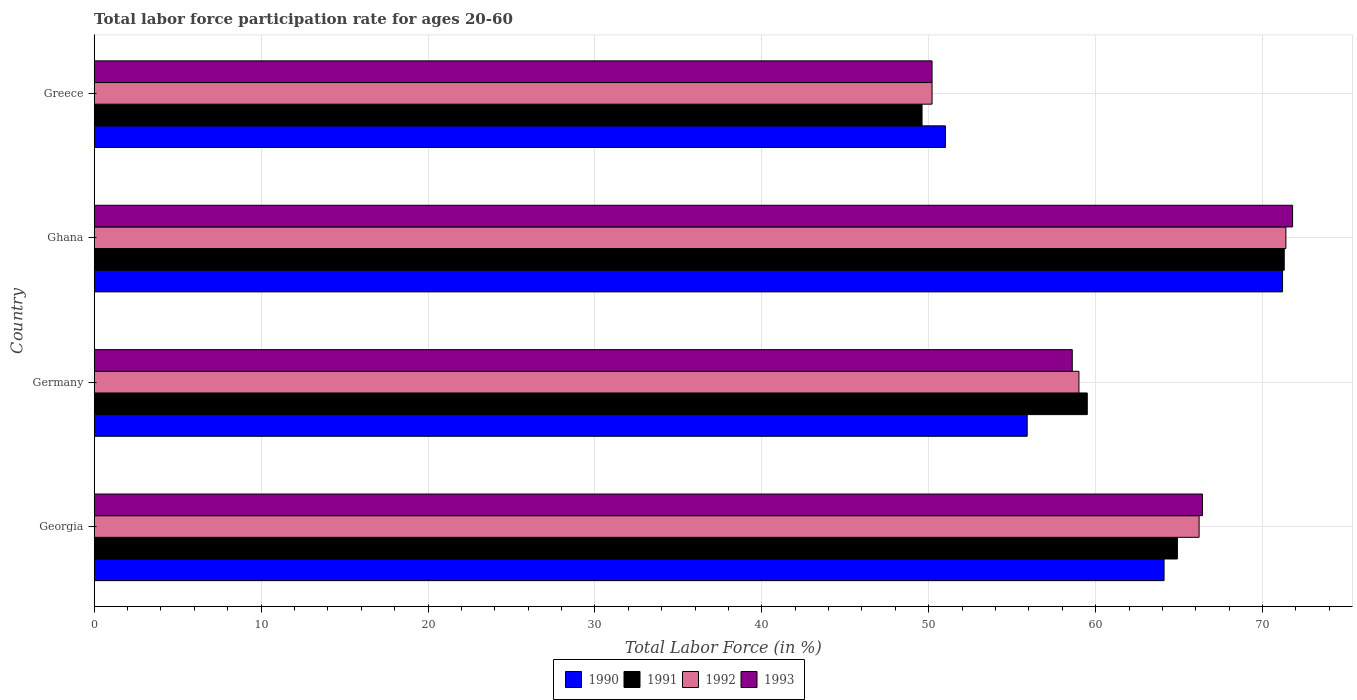Are the number of bars on each tick of the Y-axis equal?
Offer a terse response. Yes. What is the labor force participation rate in 1991 in Georgia?
Offer a terse response. 64.9. Across all countries, what is the maximum labor force participation rate in 1992?
Your answer should be very brief. 71.4. Across all countries, what is the minimum labor force participation rate in 1992?
Give a very brief answer. 50.2. In which country was the labor force participation rate in 1992 maximum?
Keep it short and to the point. Ghana. What is the total labor force participation rate in 1993 in the graph?
Keep it short and to the point. 247. What is the difference between the labor force participation rate in 1993 in Georgia and that in Germany?
Offer a very short reply. 7.8. What is the difference between the labor force participation rate in 1992 in Ghana and the labor force participation rate in 1991 in Germany?
Provide a succinct answer. 11.9. What is the average labor force participation rate in 1992 per country?
Your answer should be compact. 61.7. What is the difference between the labor force participation rate in 1991 and labor force participation rate in 1992 in Georgia?
Provide a short and direct response. -1.3. In how many countries, is the labor force participation rate in 1990 greater than 70 %?
Give a very brief answer. 1. What is the ratio of the labor force participation rate in 1992 in Germany to that in Greece?
Make the answer very short. 1.18. Is the difference between the labor force participation rate in 1991 in Ghana and Greece greater than the difference between the labor force participation rate in 1992 in Ghana and Greece?
Provide a short and direct response. Yes. What is the difference between the highest and the second highest labor force participation rate in 1993?
Your response must be concise. 5.4. What is the difference between the highest and the lowest labor force participation rate in 1992?
Give a very brief answer. 21.2. Is the sum of the labor force participation rate in 1990 in Germany and Ghana greater than the maximum labor force participation rate in 1992 across all countries?
Offer a terse response. Yes. Is it the case that in every country, the sum of the labor force participation rate in 1992 and labor force participation rate in 1990 is greater than the sum of labor force participation rate in 1993 and labor force participation rate in 1991?
Provide a short and direct response. No. What does the 2nd bar from the top in Germany represents?
Offer a very short reply. 1992. Are the values on the major ticks of X-axis written in scientific E-notation?
Offer a very short reply. No. Does the graph contain any zero values?
Make the answer very short. No. Where does the legend appear in the graph?
Keep it short and to the point. Bottom center. How many legend labels are there?
Keep it short and to the point. 4. What is the title of the graph?
Provide a succinct answer. Total labor force participation rate for ages 20-60. Does "1991" appear as one of the legend labels in the graph?
Offer a very short reply. Yes. What is the label or title of the X-axis?
Offer a terse response. Total Labor Force (in %). What is the Total Labor Force (in %) in 1990 in Georgia?
Your answer should be compact. 64.1. What is the Total Labor Force (in %) of 1991 in Georgia?
Offer a very short reply. 64.9. What is the Total Labor Force (in %) in 1992 in Georgia?
Your answer should be compact. 66.2. What is the Total Labor Force (in %) of 1993 in Georgia?
Provide a succinct answer. 66.4. What is the Total Labor Force (in %) of 1990 in Germany?
Your answer should be compact. 55.9. What is the Total Labor Force (in %) in 1991 in Germany?
Make the answer very short. 59.5. What is the Total Labor Force (in %) of 1993 in Germany?
Keep it short and to the point. 58.6. What is the Total Labor Force (in %) in 1990 in Ghana?
Offer a terse response. 71.2. What is the Total Labor Force (in %) of 1991 in Ghana?
Provide a short and direct response. 71.3. What is the Total Labor Force (in %) of 1992 in Ghana?
Keep it short and to the point. 71.4. What is the Total Labor Force (in %) in 1993 in Ghana?
Provide a succinct answer. 71.8. What is the Total Labor Force (in %) of 1990 in Greece?
Your answer should be very brief. 51. What is the Total Labor Force (in %) in 1991 in Greece?
Make the answer very short. 49.6. What is the Total Labor Force (in %) of 1992 in Greece?
Make the answer very short. 50.2. What is the Total Labor Force (in %) of 1993 in Greece?
Offer a terse response. 50.2. Across all countries, what is the maximum Total Labor Force (in %) in 1990?
Give a very brief answer. 71.2. Across all countries, what is the maximum Total Labor Force (in %) of 1991?
Your answer should be very brief. 71.3. Across all countries, what is the maximum Total Labor Force (in %) in 1992?
Your answer should be very brief. 71.4. Across all countries, what is the maximum Total Labor Force (in %) in 1993?
Provide a short and direct response. 71.8. Across all countries, what is the minimum Total Labor Force (in %) in 1990?
Ensure brevity in your answer.  51. Across all countries, what is the minimum Total Labor Force (in %) in 1991?
Your response must be concise. 49.6. Across all countries, what is the minimum Total Labor Force (in %) of 1992?
Offer a very short reply. 50.2. Across all countries, what is the minimum Total Labor Force (in %) of 1993?
Offer a terse response. 50.2. What is the total Total Labor Force (in %) in 1990 in the graph?
Keep it short and to the point. 242.2. What is the total Total Labor Force (in %) of 1991 in the graph?
Your response must be concise. 245.3. What is the total Total Labor Force (in %) in 1992 in the graph?
Give a very brief answer. 246.8. What is the total Total Labor Force (in %) in 1993 in the graph?
Give a very brief answer. 247. What is the difference between the Total Labor Force (in %) of 1990 in Georgia and that in Germany?
Provide a succinct answer. 8.2. What is the difference between the Total Labor Force (in %) of 1993 in Georgia and that in Greece?
Your answer should be very brief. 16.2. What is the difference between the Total Labor Force (in %) in 1990 in Germany and that in Ghana?
Make the answer very short. -15.3. What is the difference between the Total Labor Force (in %) of 1991 in Germany and that in Ghana?
Make the answer very short. -11.8. What is the difference between the Total Labor Force (in %) in 1993 in Germany and that in Ghana?
Your answer should be compact. -13.2. What is the difference between the Total Labor Force (in %) in 1990 in Germany and that in Greece?
Keep it short and to the point. 4.9. What is the difference between the Total Labor Force (in %) of 1991 in Germany and that in Greece?
Provide a succinct answer. 9.9. What is the difference between the Total Labor Force (in %) in 1992 in Germany and that in Greece?
Provide a short and direct response. 8.8. What is the difference between the Total Labor Force (in %) of 1990 in Ghana and that in Greece?
Your answer should be very brief. 20.2. What is the difference between the Total Labor Force (in %) in 1991 in Ghana and that in Greece?
Ensure brevity in your answer.  21.7. What is the difference between the Total Labor Force (in %) in 1992 in Ghana and that in Greece?
Offer a very short reply. 21.2. What is the difference between the Total Labor Force (in %) in 1993 in Ghana and that in Greece?
Your answer should be very brief. 21.6. What is the difference between the Total Labor Force (in %) of 1990 in Georgia and the Total Labor Force (in %) of 1991 in Germany?
Offer a very short reply. 4.6. What is the difference between the Total Labor Force (in %) of 1990 in Georgia and the Total Labor Force (in %) of 1992 in Germany?
Offer a terse response. 5.1. What is the difference between the Total Labor Force (in %) in 1990 in Georgia and the Total Labor Force (in %) in 1993 in Germany?
Ensure brevity in your answer.  5.5. What is the difference between the Total Labor Force (in %) of 1992 in Georgia and the Total Labor Force (in %) of 1993 in Germany?
Keep it short and to the point. 7.6. What is the difference between the Total Labor Force (in %) of 1990 in Georgia and the Total Labor Force (in %) of 1993 in Ghana?
Offer a very short reply. -7.7. What is the difference between the Total Labor Force (in %) in 1991 in Georgia and the Total Labor Force (in %) in 1992 in Ghana?
Your answer should be very brief. -6.5. What is the difference between the Total Labor Force (in %) in 1992 in Georgia and the Total Labor Force (in %) in 1993 in Ghana?
Your response must be concise. -5.6. What is the difference between the Total Labor Force (in %) of 1990 in Georgia and the Total Labor Force (in %) of 1991 in Greece?
Your answer should be compact. 14.5. What is the difference between the Total Labor Force (in %) of 1990 in Georgia and the Total Labor Force (in %) of 1992 in Greece?
Your response must be concise. 13.9. What is the difference between the Total Labor Force (in %) in 1990 in Georgia and the Total Labor Force (in %) in 1993 in Greece?
Offer a very short reply. 13.9. What is the difference between the Total Labor Force (in %) in 1991 in Georgia and the Total Labor Force (in %) in 1992 in Greece?
Offer a very short reply. 14.7. What is the difference between the Total Labor Force (in %) in 1992 in Georgia and the Total Labor Force (in %) in 1993 in Greece?
Keep it short and to the point. 16. What is the difference between the Total Labor Force (in %) in 1990 in Germany and the Total Labor Force (in %) in 1991 in Ghana?
Your answer should be very brief. -15.4. What is the difference between the Total Labor Force (in %) in 1990 in Germany and the Total Labor Force (in %) in 1992 in Ghana?
Provide a short and direct response. -15.5. What is the difference between the Total Labor Force (in %) of 1990 in Germany and the Total Labor Force (in %) of 1993 in Ghana?
Ensure brevity in your answer.  -15.9. What is the difference between the Total Labor Force (in %) of 1991 in Germany and the Total Labor Force (in %) of 1992 in Ghana?
Provide a succinct answer. -11.9. What is the difference between the Total Labor Force (in %) in 1991 in Germany and the Total Labor Force (in %) in 1993 in Ghana?
Offer a terse response. -12.3. What is the difference between the Total Labor Force (in %) of 1992 in Germany and the Total Labor Force (in %) of 1993 in Ghana?
Offer a terse response. -12.8. What is the difference between the Total Labor Force (in %) of 1990 in Germany and the Total Labor Force (in %) of 1993 in Greece?
Keep it short and to the point. 5.7. What is the difference between the Total Labor Force (in %) in 1991 in Germany and the Total Labor Force (in %) in 1993 in Greece?
Provide a short and direct response. 9.3. What is the difference between the Total Labor Force (in %) in 1990 in Ghana and the Total Labor Force (in %) in 1991 in Greece?
Your answer should be very brief. 21.6. What is the difference between the Total Labor Force (in %) of 1990 in Ghana and the Total Labor Force (in %) of 1992 in Greece?
Offer a terse response. 21. What is the difference between the Total Labor Force (in %) in 1990 in Ghana and the Total Labor Force (in %) in 1993 in Greece?
Ensure brevity in your answer.  21. What is the difference between the Total Labor Force (in %) in 1991 in Ghana and the Total Labor Force (in %) in 1992 in Greece?
Make the answer very short. 21.1. What is the difference between the Total Labor Force (in %) of 1991 in Ghana and the Total Labor Force (in %) of 1993 in Greece?
Keep it short and to the point. 21.1. What is the difference between the Total Labor Force (in %) of 1992 in Ghana and the Total Labor Force (in %) of 1993 in Greece?
Give a very brief answer. 21.2. What is the average Total Labor Force (in %) in 1990 per country?
Ensure brevity in your answer.  60.55. What is the average Total Labor Force (in %) of 1991 per country?
Offer a terse response. 61.33. What is the average Total Labor Force (in %) of 1992 per country?
Offer a very short reply. 61.7. What is the average Total Labor Force (in %) in 1993 per country?
Make the answer very short. 61.75. What is the difference between the Total Labor Force (in %) in 1990 and Total Labor Force (in %) in 1991 in Georgia?
Make the answer very short. -0.8. What is the difference between the Total Labor Force (in %) of 1990 and Total Labor Force (in %) of 1992 in Georgia?
Offer a very short reply. -2.1. What is the difference between the Total Labor Force (in %) in 1990 and Total Labor Force (in %) in 1993 in Georgia?
Offer a very short reply. -2.3. What is the difference between the Total Labor Force (in %) in 1991 and Total Labor Force (in %) in 1992 in Georgia?
Keep it short and to the point. -1.3. What is the difference between the Total Labor Force (in %) in 1991 and Total Labor Force (in %) in 1993 in Georgia?
Your answer should be compact. -1.5. What is the difference between the Total Labor Force (in %) of 1991 and Total Labor Force (in %) of 1992 in Germany?
Make the answer very short. 0.5. What is the difference between the Total Labor Force (in %) in 1990 and Total Labor Force (in %) in 1993 in Ghana?
Provide a short and direct response. -0.6. What is the difference between the Total Labor Force (in %) of 1991 and Total Labor Force (in %) of 1993 in Ghana?
Give a very brief answer. -0.5. What is the difference between the Total Labor Force (in %) in 1990 and Total Labor Force (in %) in 1992 in Greece?
Give a very brief answer. 0.8. What is the difference between the Total Labor Force (in %) of 1992 and Total Labor Force (in %) of 1993 in Greece?
Ensure brevity in your answer.  0. What is the ratio of the Total Labor Force (in %) in 1990 in Georgia to that in Germany?
Your answer should be very brief. 1.15. What is the ratio of the Total Labor Force (in %) in 1991 in Georgia to that in Germany?
Keep it short and to the point. 1.09. What is the ratio of the Total Labor Force (in %) of 1992 in Georgia to that in Germany?
Make the answer very short. 1.12. What is the ratio of the Total Labor Force (in %) in 1993 in Georgia to that in Germany?
Offer a terse response. 1.13. What is the ratio of the Total Labor Force (in %) in 1990 in Georgia to that in Ghana?
Your answer should be compact. 0.9. What is the ratio of the Total Labor Force (in %) in 1991 in Georgia to that in Ghana?
Provide a short and direct response. 0.91. What is the ratio of the Total Labor Force (in %) of 1992 in Georgia to that in Ghana?
Give a very brief answer. 0.93. What is the ratio of the Total Labor Force (in %) of 1993 in Georgia to that in Ghana?
Keep it short and to the point. 0.92. What is the ratio of the Total Labor Force (in %) in 1990 in Georgia to that in Greece?
Provide a succinct answer. 1.26. What is the ratio of the Total Labor Force (in %) in 1991 in Georgia to that in Greece?
Give a very brief answer. 1.31. What is the ratio of the Total Labor Force (in %) in 1992 in Georgia to that in Greece?
Ensure brevity in your answer.  1.32. What is the ratio of the Total Labor Force (in %) in 1993 in Georgia to that in Greece?
Provide a short and direct response. 1.32. What is the ratio of the Total Labor Force (in %) in 1990 in Germany to that in Ghana?
Your response must be concise. 0.79. What is the ratio of the Total Labor Force (in %) of 1991 in Germany to that in Ghana?
Provide a succinct answer. 0.83. What is the ratio of the Total Labor Force (in %) of 1992 in Germany to that in Ghana?
Your answer should be compact. 0.83. What is the ratio of the Total Labor Force (in %) of 1993 in Germany to that in Ghana?
Offer a terse response. 0.82. What is the ratio of the Total Labor Force (in %) in 1990 in Germany to that in Greece?
Provide a short and direct response. 1.1. What is the ratio of the Total Labor Force (in %) of 1991 in Germany to that in Greece?
Provide a succinct answer. 1.2. What is the ratio of the Total Labor Force (in %) in 1992 in Germany to that in Greece?
Provide a short and direct response. 1.18. What is the ratio of the Total Labor Force (in %) in 1993 in Germany to that in Greece?
Offer a terse response. 1.17. What is the ratio of the Total Labor Force (in %) of 1990 in Ghana to that in Greece?
Provide a short and direct response. 1.4. What is the ratio of the Total Labor Force (in %) of 1991 in Ghana to that in Greece?
Make the answer very short. 1.44. What is the ratio of the Total Labor Force (in %) in 1992 in Ghana to that in Greece?
Offer a terse response. 1.42. What is the ratio of the Total Labor Force (in %) of 1993 in Ghana to that in Greece?
Your answer should be very brief. 1.43. What is the difference between the highest and the second highest Total Labor Force (in %) in 1991?
Offer a terse response. 6.4. What is the difference between the highest and the second highest Total Labor Force (in %) in 1992?
Make the answer very short. 5.2. What is the difference between the highest and the second highest Total Labor Force (in %) in 1993?
Your answer should be compact. 5.4. What is the difference between the highest and the lowest Total Labor Force (in %) of 1990?
Offer a terse response. 20.2. What is the difference between the highest and the lowest Total Labor Force (in %) of 1991?
Your answer should be very brief. 21.7. What is the difference between the highest and the lowest Total Labor Force (in %) in 1992?
Provide a succinct answer. 21.2. What is the difference between the highest and the lowest Total Labor Force (in %) in 1993?
Your response must be concise. 21.6. 